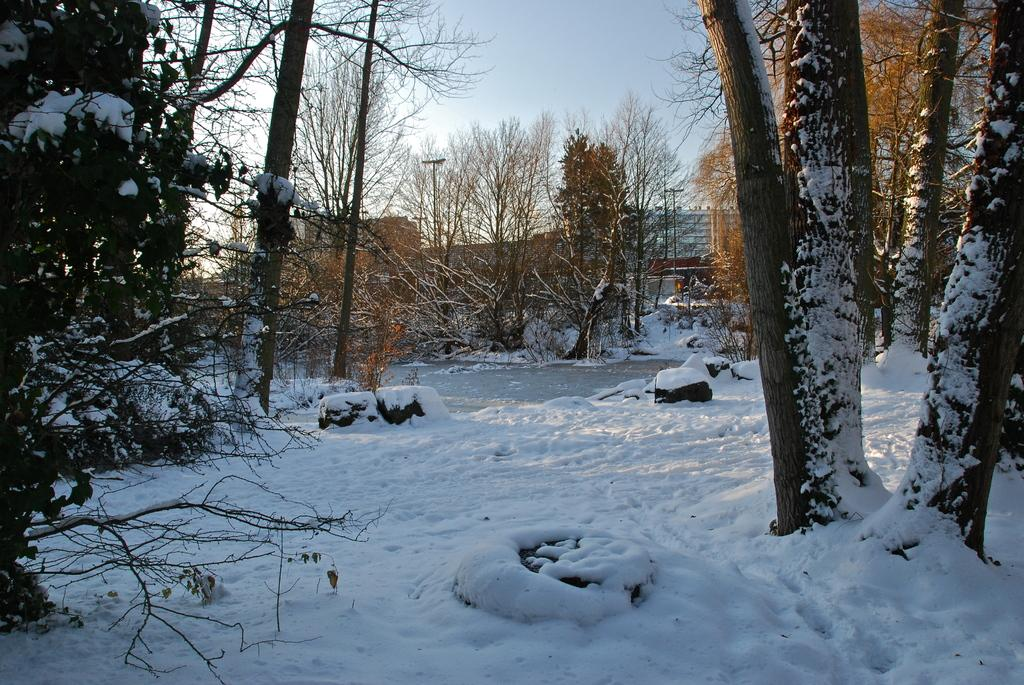What type of weather condition is depicted at the bottom of the image? There is snow at the bottom of the image. What can be seen on either side of the image? There are trees on either side of the image. How are the trees affected by the snow? The trees are covered with snow. What structure can be seen in the background of the image? There is a building in the background of the image. How many chickens are perched on the branches of the trees in the image? There are no chickens present in the image; the trees are covered with snow. What type of oil can be seen dripping from the branches of the trees in the image? There is no oil present in the image; the trees are covered with snow. 